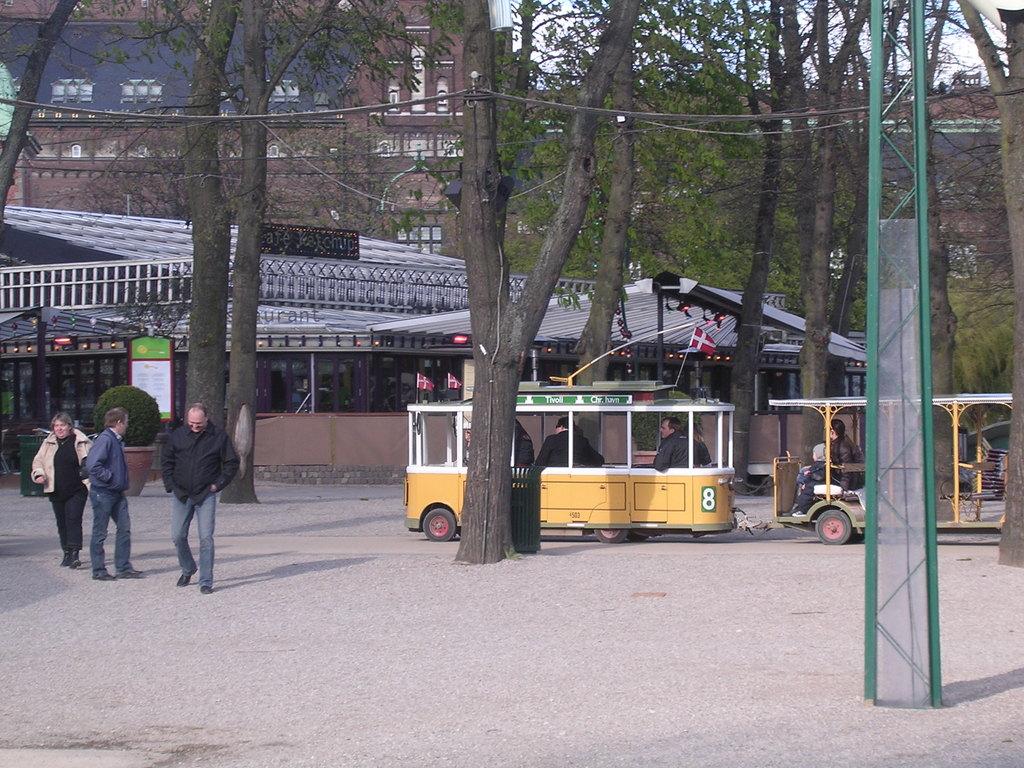What is this trolley numbered?
Ensure brevity in your answer.  8. 